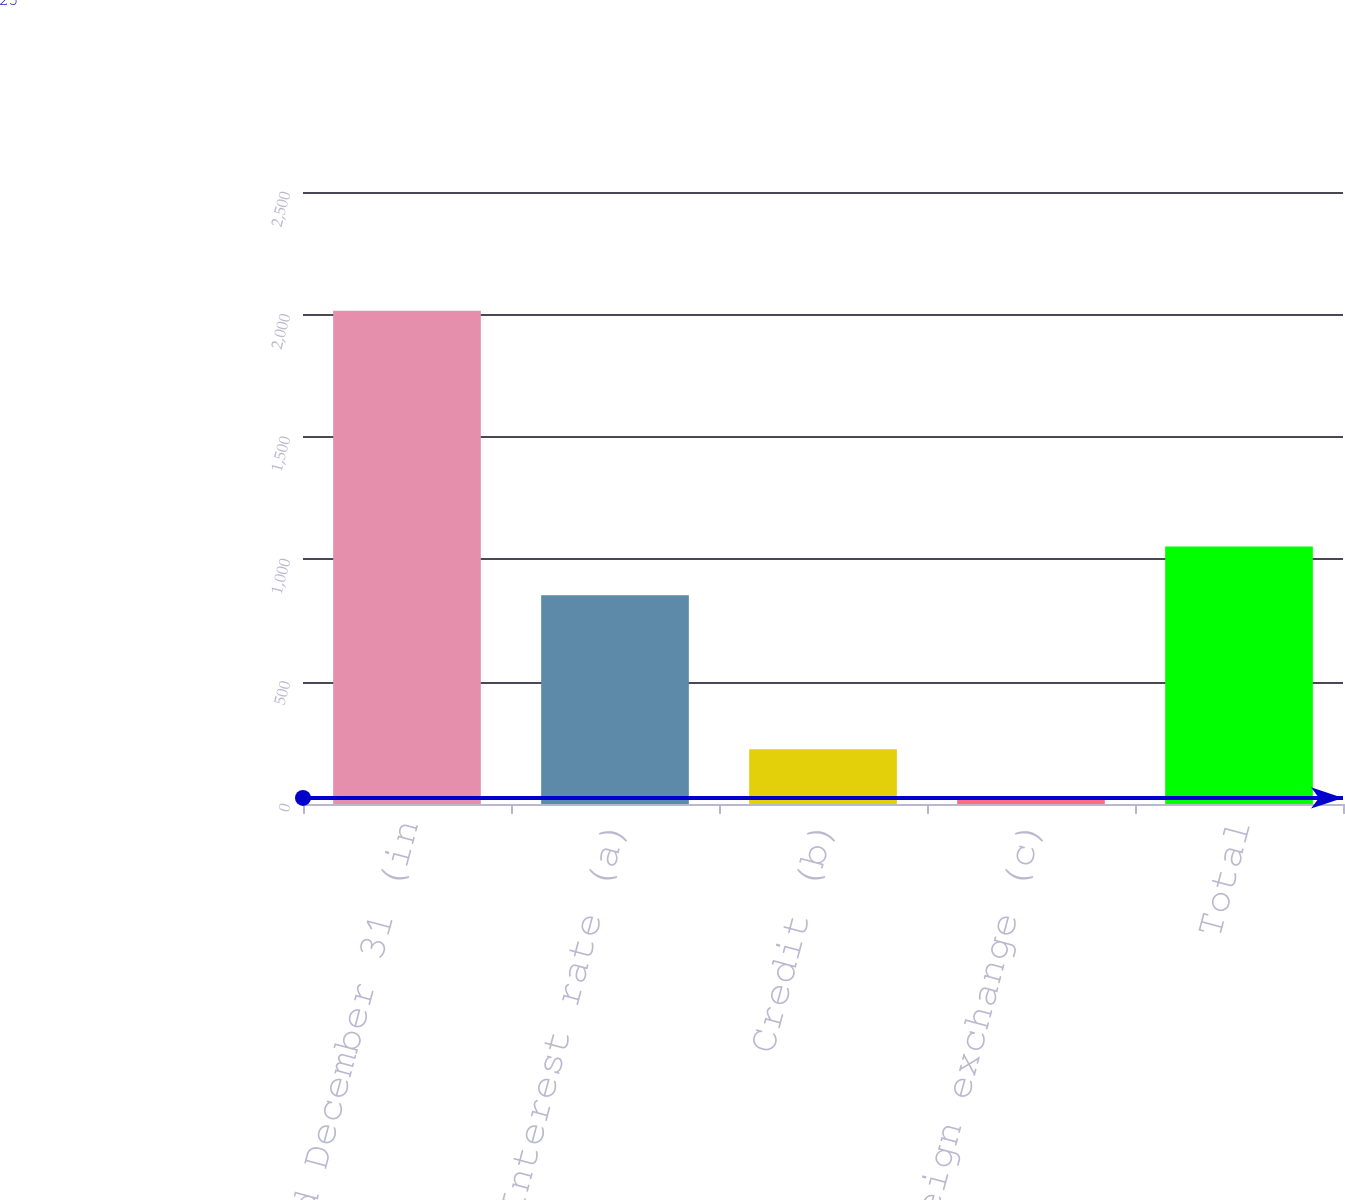Convert chart. <chart><loc_0><loc_0><loc_500><loc_500><bar_chart><fcel>Year ended December 31 (in<fcel>Interest rate (a)<fcel>Credit (b)<fcel>Foreign exchange (c)<fcel>Total<nl><fcel>2015<fcel>853<fcel>224<fcel>25<fcel>1052<nl></chart> 